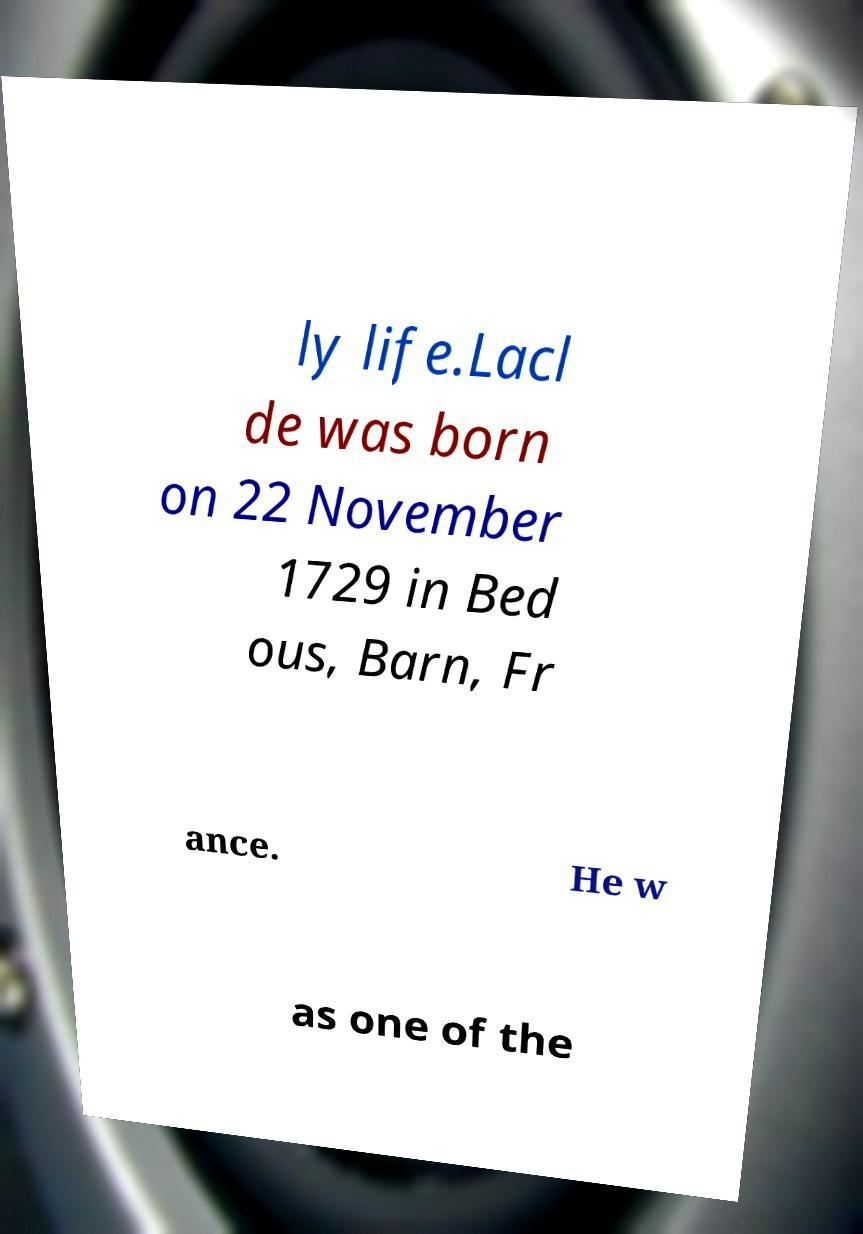What messages or text are displayed in this image? I need them in a readable, typed format. ly life.Lacl de was born on 22 November 1729 in Bed ous, Barn, Fr ance. He w as one of the 